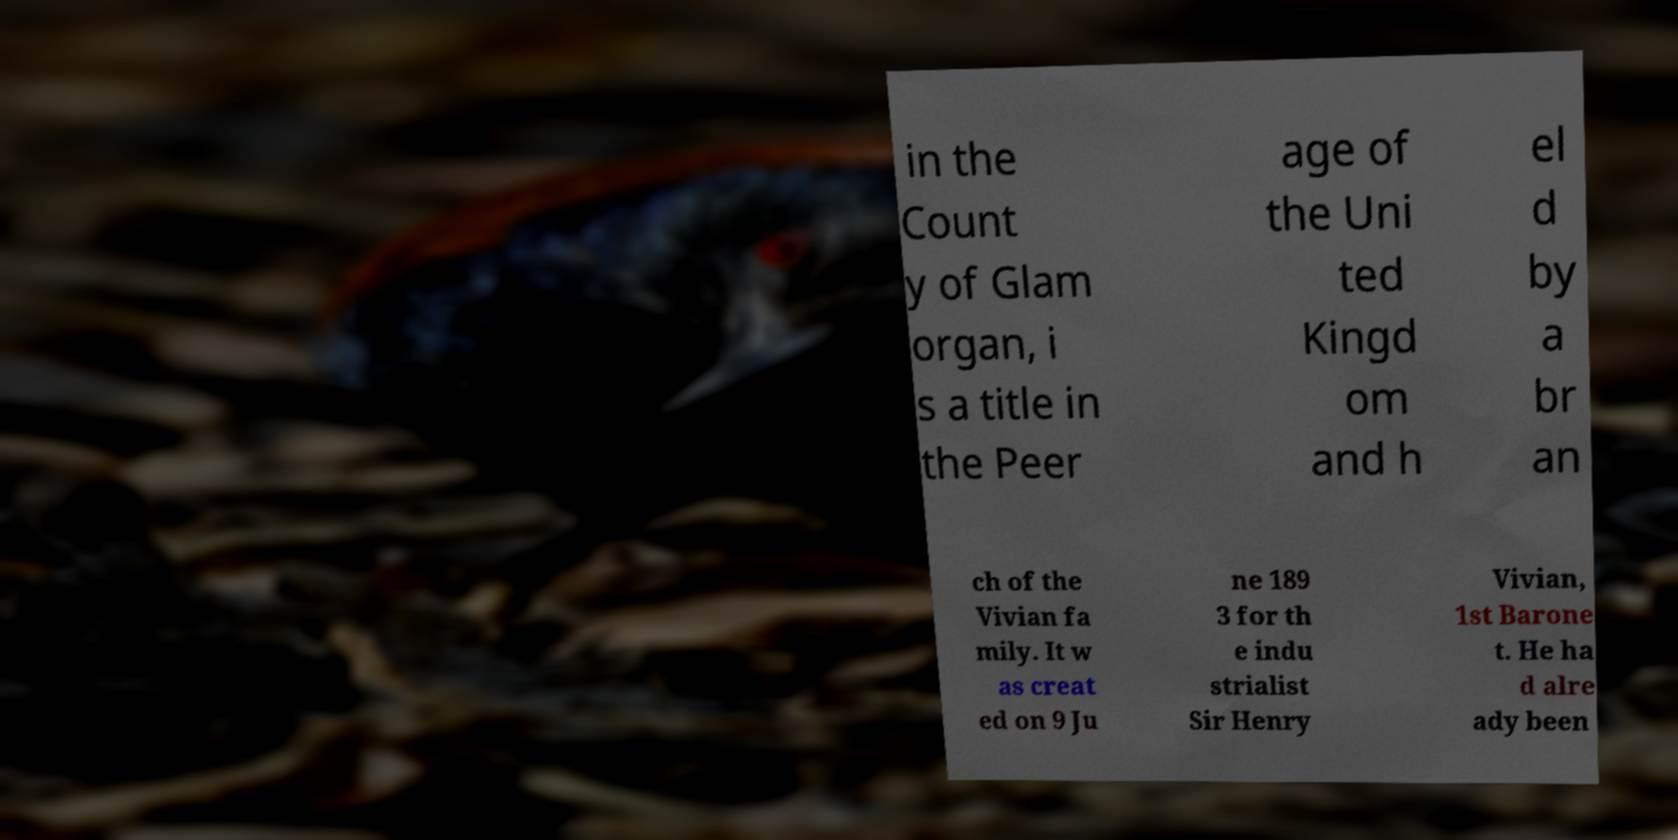Can you accurately transcribe the text from the provided image for me? in the Count y of Glam organ, i s a title in the Peer age of the Uni ted Kingd om and h el d by a br an ch of the Vivian fa mily. It w as creat ed on 9 Ju ne 189 3 for th e indu strialist Sir Henry Vivian, 1st Barone t. He ha d alre ady been 